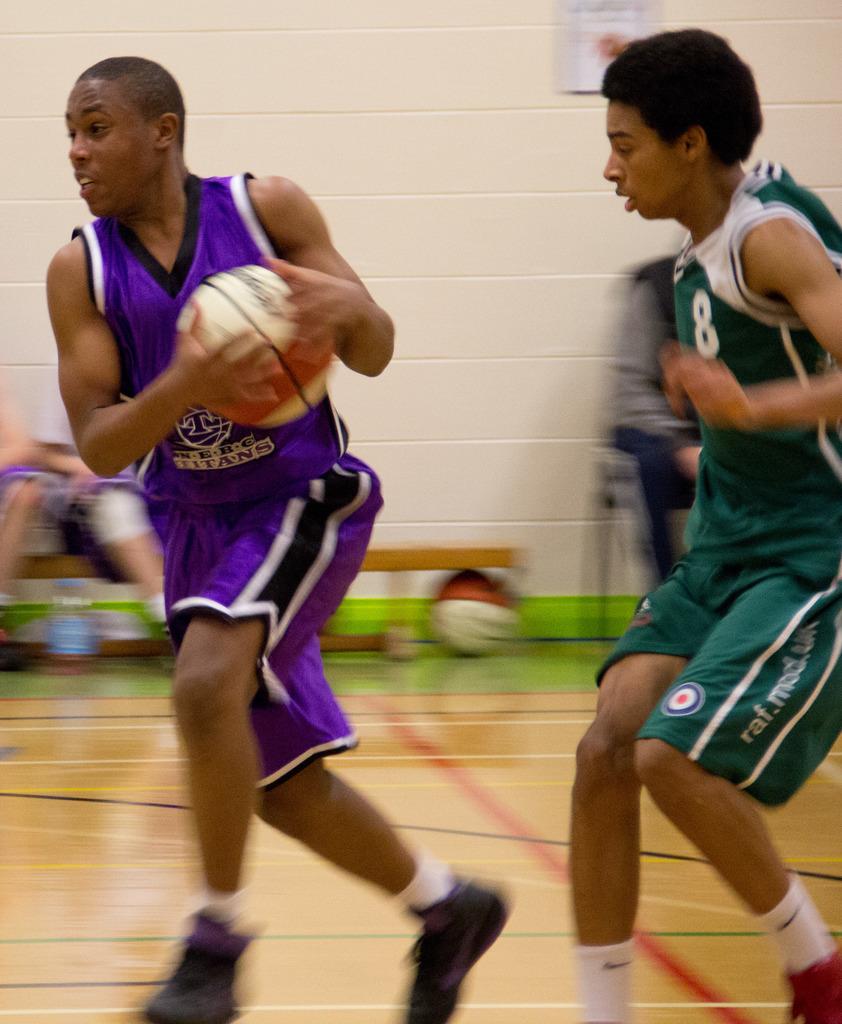What is the player's number?
Offer a terse response. 8. 